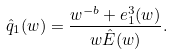Convert formula to latex. <formula><loc_0><loc_0><loc_500><loc_500>\hat { q } _ { 1 } ( w ) = \frac { w ^ { - b } + e ^ { 3 } _ { 1 } ( w ) } { w \hat { E } ( w ) } .</formula> 